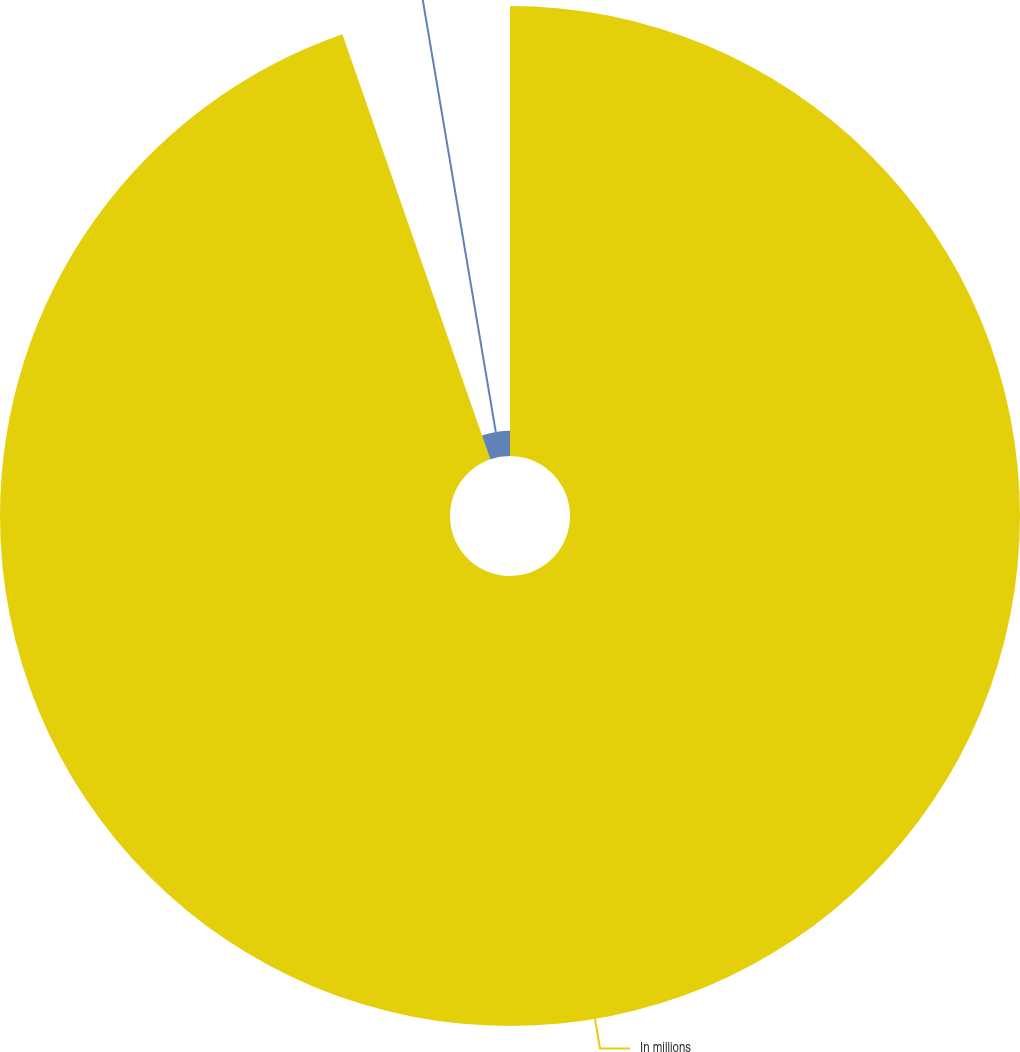Convert chart. <chart><loc_0><loc_0><loc_500><loc_500><pie_chart><fcel>In millions<fcel>Rent expense<nl><fcel>94.67%<fcel>5.33%<nl></chart> 